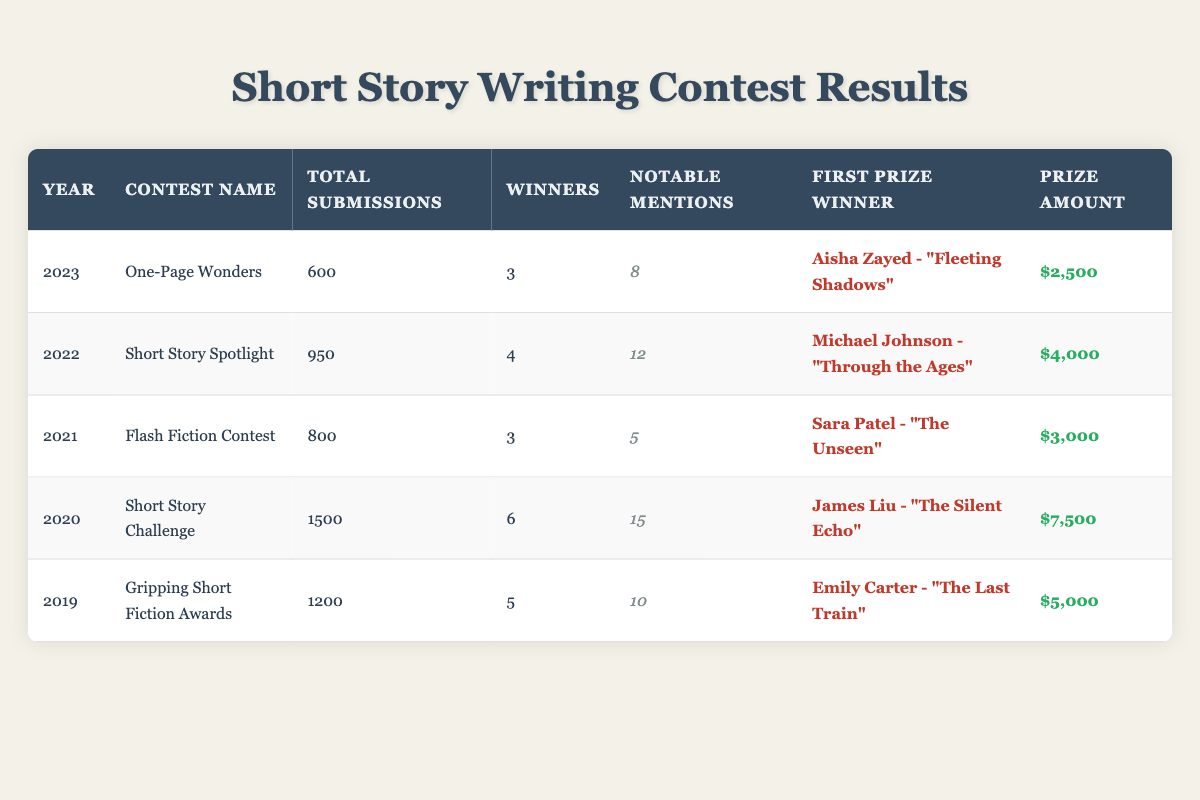What was the total number of submissions in 2020? Looking at the table, the column for Total Submissions in the year 2020 shows 1500 submissions.
Answer: 1500 Who won the first prize in the year 2022? According to the table, the winner of the first prize in 2022 was Michael Johnson for the story titled "Through the Ages."
Answer: Michael Johnson How many total winners were there in 2019 and 2021? In 2019, there were 5 winners, and in 2021 there were 3 winners. Adding these together gives 5 + 3 = 8 winners in total for both years.
Answer: 8 Which contest had the highest prize amount, and how much was it? By examining the Prize Amount column, the contest with the highest prize amount was the "Short Story Challenge" in 2020, with a prize of $7,500.
Answer: Short Story Challenge, $7,500 Was the total number of submissions in 2023 greater than the total submissions in 2021? In 2023, there were 600 submissions, and in 2021 there were 800 submissions. Since 600 is less than 800, the answer is no.
Answer: No What is the average prize amount awarded between 2019 and 2023? The prize amounts for those years are $5,000 (2019), $7,500 (2020), $3,000 (2021), $4,000 (2022), and $2,500 (2023). First, we sum these amounts: 5000 + 7500 + 3000 + 4000 + 2500 = $22,000. Then we divide by 5 (the number of years): $22,000 / 5 = $4,400.
Answer: $4,400 How many notable mentions did the "One-Page Wonders" contest receive? Looking at the Notable Mentions column for the "One-Page Wonders" contest in 2023, it received 8 notable mentions.
Answer: 8 Which contest had fewer submissions: "Flash Fiction Contest" or "One-Page Wonders"? The "Flash Fiction Contest" had 800 submissions, while the "One-Page Wonders" had 600 submissions. Since 600 is lower than 800, "One-Page Wonders" had fewer submissions.
Answer: One-Page Wonders Was there an increase in the number of total submissions from 2019 to 2020? The number of submissions in 2019 was 1200 and in 2020 it was 1500. Since 1500 is greater than 1200, there was an increase.
Answer: Yes 